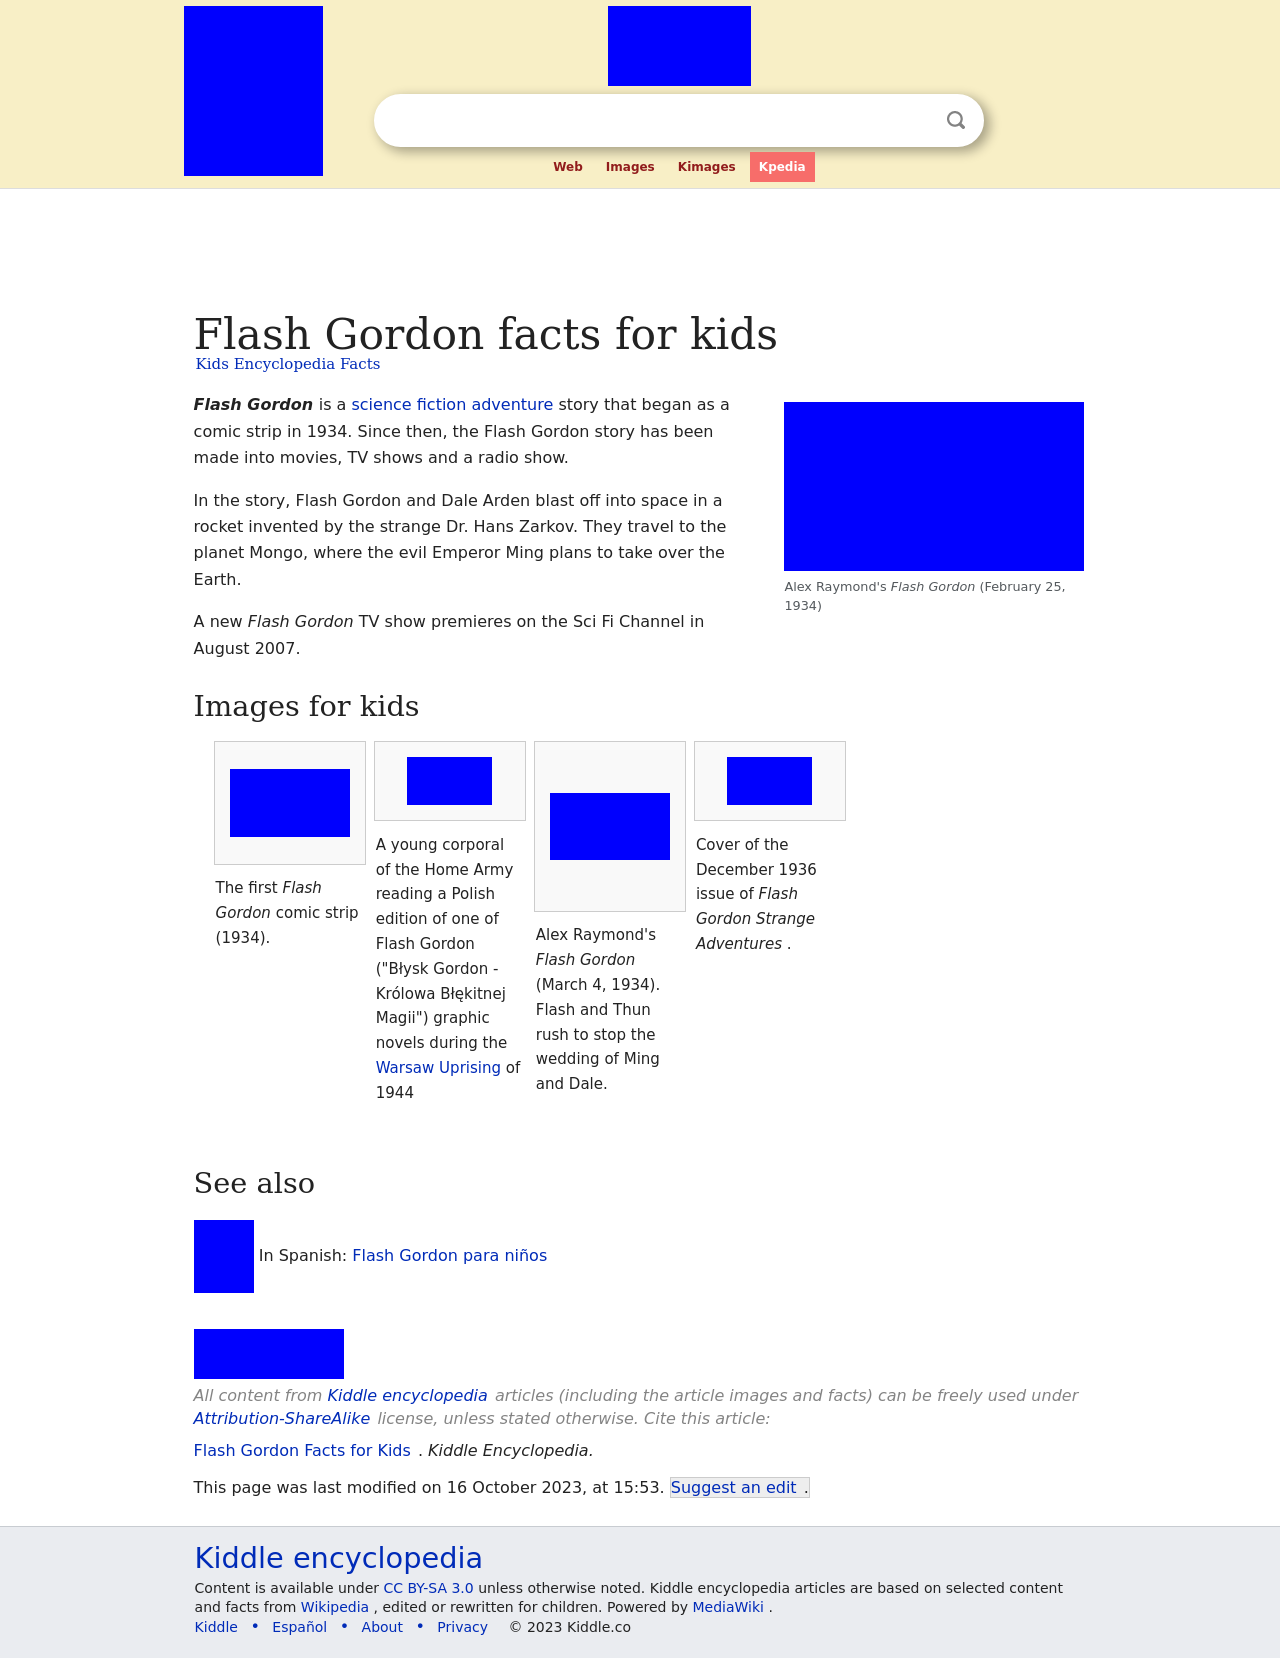How can I start building this website with HTML from the ground up? To start building a website from the ground up using HTML, begin by creating a basic HTML document structure. Here's a simple example:

<!DOCTYPE html>
<html>
<head>
  <title>Your Website Title</title>
</head>
<body>
  <h1>Welcome to My Website</h1>
  <p>This is a paragraph of text to introduce the website's purpose.</p>
</body>
</html>

This structure includes the essential components: a DOCTYPE declaration, html tag, head section with a title, and a body section with a heading and a paragraph. Start by saving this as an 'index.html' file and open it in a web browser to see your basic website. 